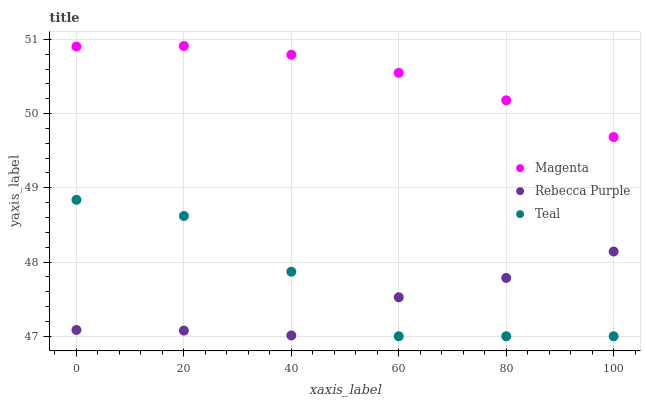Does Rebecca Purple have the minimum area under the curve?
Answer yes or no. Yes. Does Magenta have the maximum area under the curve?
Answer yes or no. Yes. Does Teal have the minimum area under the curve?
Answer yes or no. No. Does Teal have the maximum area under the curve?
Answer yes or no. No. Is Magenta the smoothest?
Answer yes or no. Yes. Is Teal the roughest?
Answer yes or no. Yes. Is Rebecca Purple the smoothest?
Answer yes or no. No. Is Rebecca Purple the roughest?
Answer yes or no. No. Does Teal have the lowest value?
Answer yes or no. Yes. Does Rebecca Purple have the lowest value?
Answer yes or no. No. Does Magenta have the highest value?
Answer yes or no. Yes. Does Teal have the highest value?
Answer yes or no. No. Is Teal less than Magenta?
Answer yes or no. Yes. Is Magenta greater than Teal?
Answer yes or no. Yes. Does Rebecca Purple intersect Teal?
Answer yes or no. Yes. Is Rebecca Purple less than Teal?
Answer yes or no. No. Is Rebecca Purple greater than Teal?
Answer yes or no. No. Does Teal intersect Magenta?
Answer yes or no. No. 